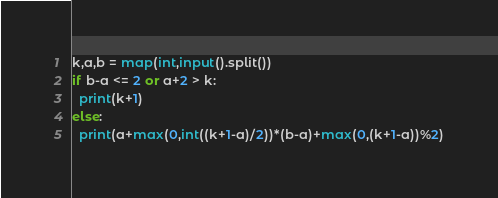Convert code to text. <code><loc_0><loc_0><loc_500><loc_500><_Python_>k,a,b = map(int,input().split())
if b-a <= 2 or a+2 > k:
  print(k+1)
else:
  print(a+max(0,int((k+1-a)/2))*(b-a)+max(0,(k+1-a))%2)
</code> 